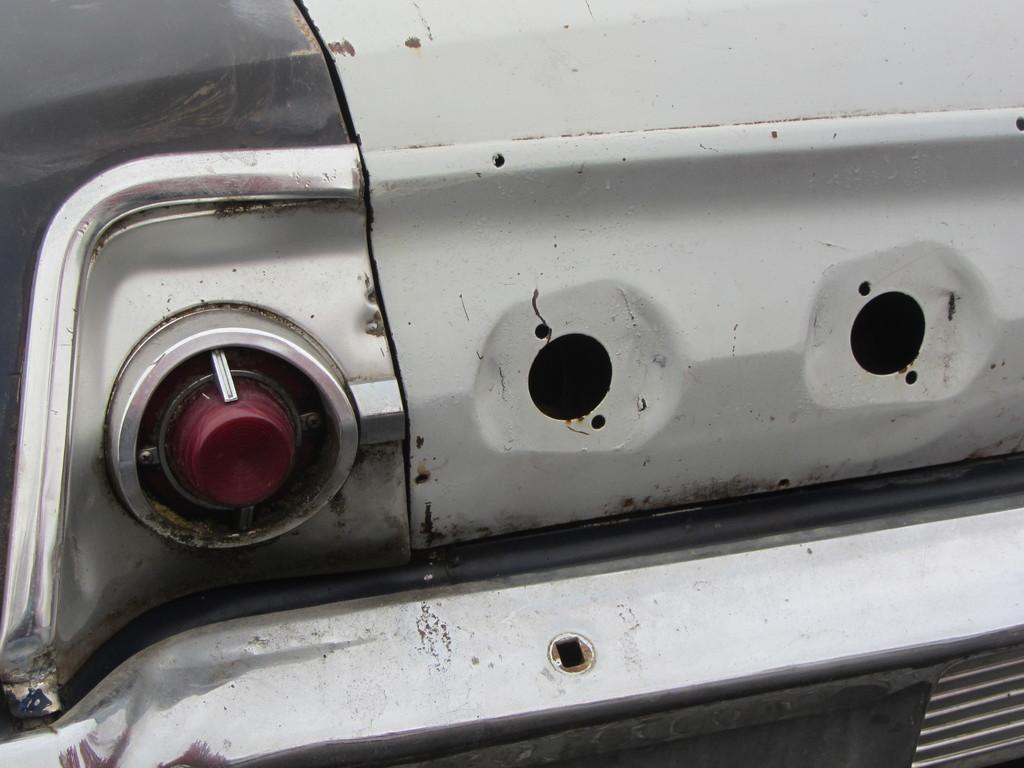Describe this image in one or two sentences. In this image there is a car with a tail light. 